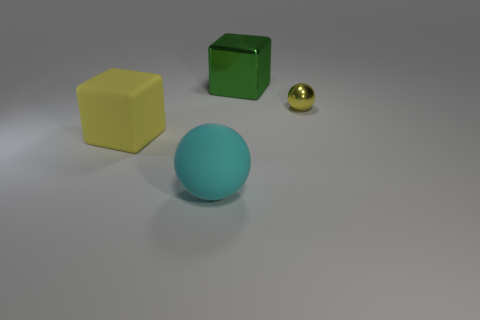Add 4 tiny balls. How many objects exist? 8 Add 4 cyan objects. How many cyan objects are left? 5 Add 3 green blocks. How many green blocks exist? 4 Subtract 0 blue balls. How many objects are left? 4 Subtract all tiny red cylinders. Subtract all big metal things. How many objects are left? 3 